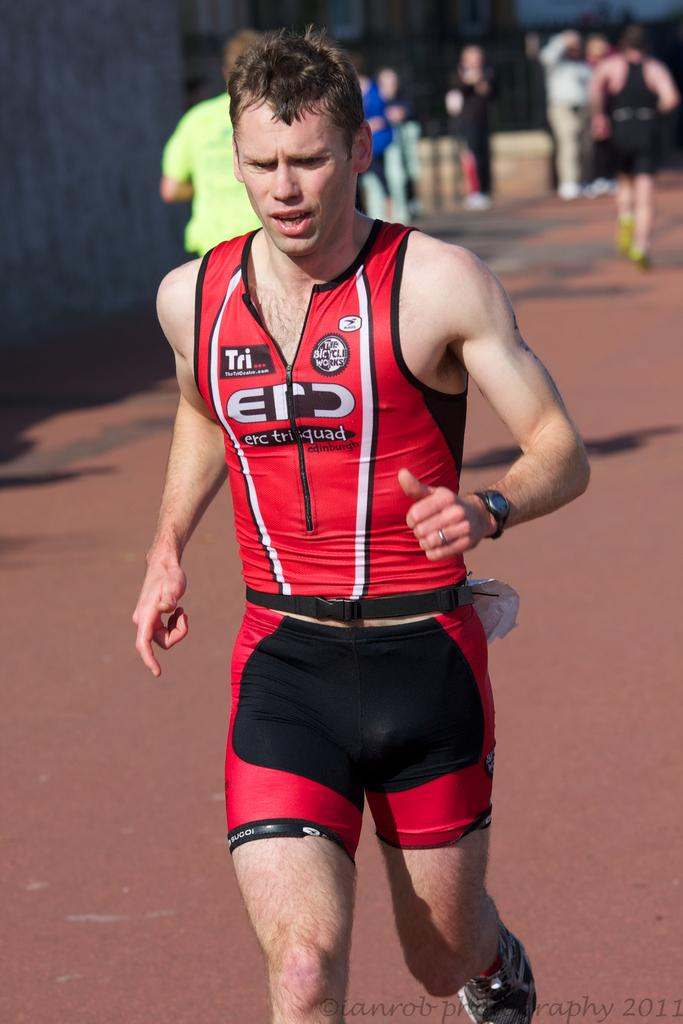<image>
Create a compact narrative representing the image presented. Runner in a red jersey and shorts that has Tri on the right side of the jersey. 